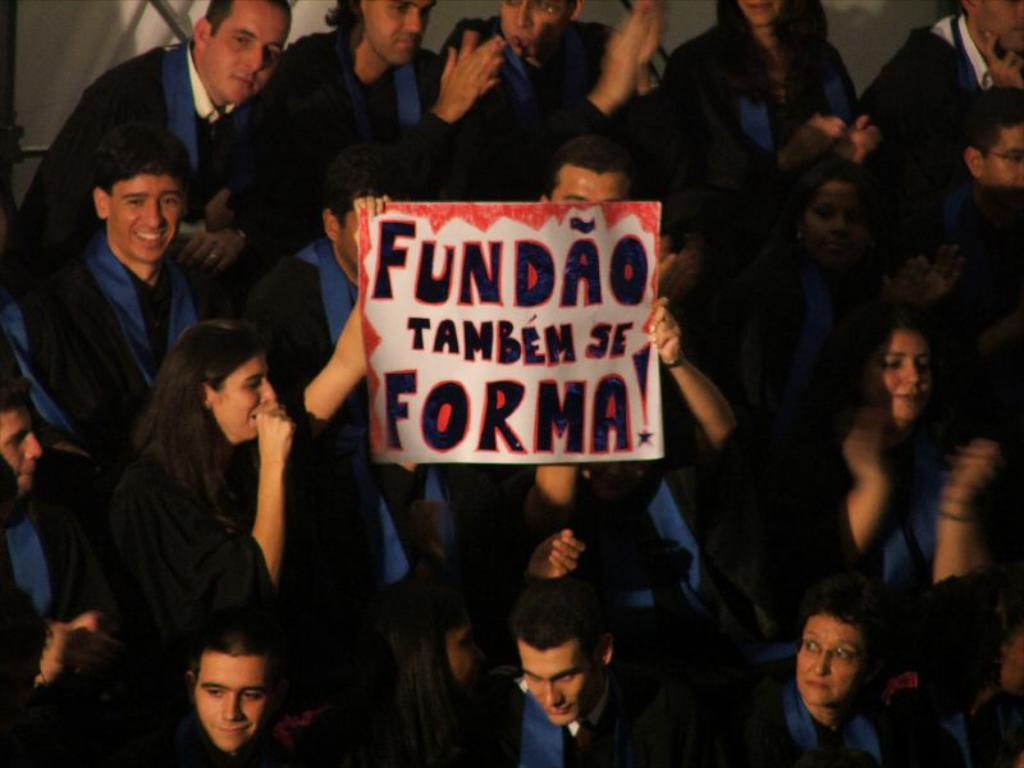Who or what is present in the image? There are people in the image. What are the people wearing? The people are wearing black coats. What are the people doing in the image? The people are standing. What object can be seen in the image besides the people? There is a placard in the image. What information is provided on the placard? There is text written on the placard. What type of bell can be heard ringing in the image? There is no bell present or ringing in the image. What type of prison is depicted in the image? There is no prison depicted in the image; it features people wearing black coats and standing with a placard. 